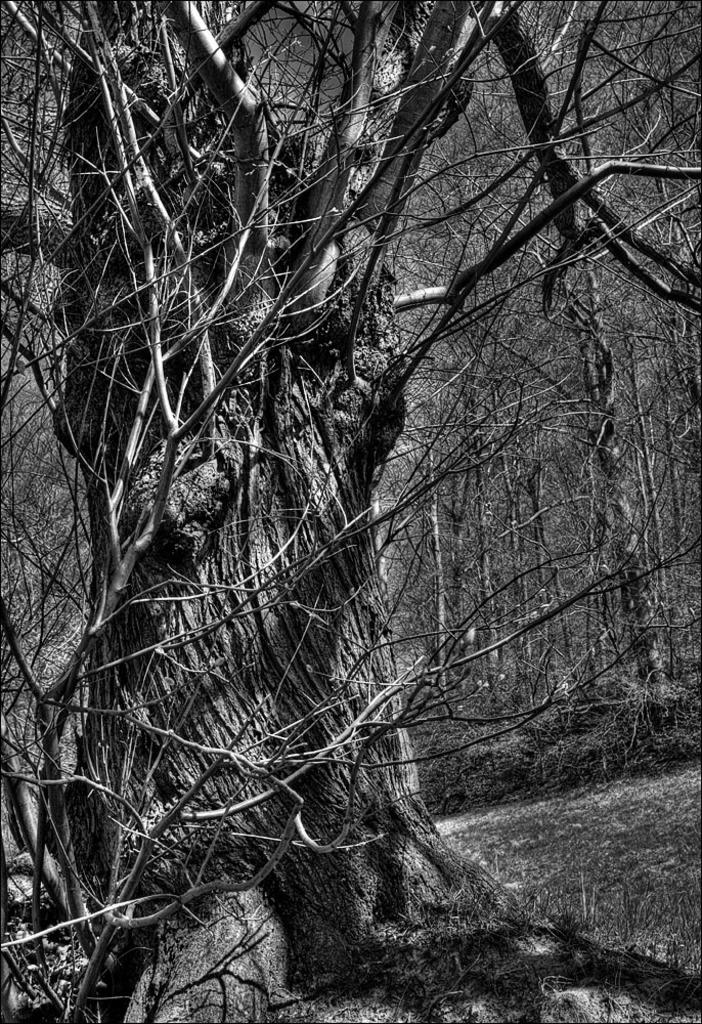What is the color scheme of the image? The image is black and white. What is the main subject in the foreground of the image? There is a tree in the front of the image. What type of terrain is the tree located on? The tree is on a grassland. What can be seen in the background of the image? There are many trees visible in the background of the image. Can you hear the bell ringing in the image? There is no bell present in the image, so it cannot be heard. 